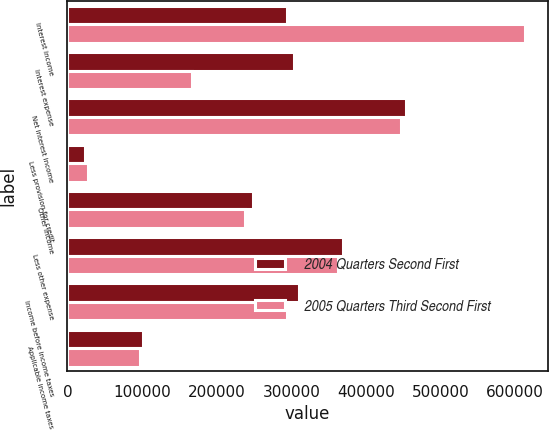Convert chart. <chart><loc_0><loc_0><loc_500><loc_500><stacked_bar_chart><ecel><fcel>Interest income<fcel>Interest expense<fcel>Net interest income<fcel>Less provision for credit<fcel>Other income<fcel>Less other expense<fcel>Income before income taxes<fcel>Applicable income taxes<nl><fcel>2004 Quarters Second First<fcel>293894<fcel>303493<fcel>454161<fcel>23000<fcel>248604<fcel>369114<fcel>310651<fcel>101113<nl><fcel>2005 Quarters Third Second First<fcel>613012<fcel>166755<fcel>446257<fcel>28000<fcel>237559<fcel>361922<fcel>293894<fcel>97624<nl></chart> 